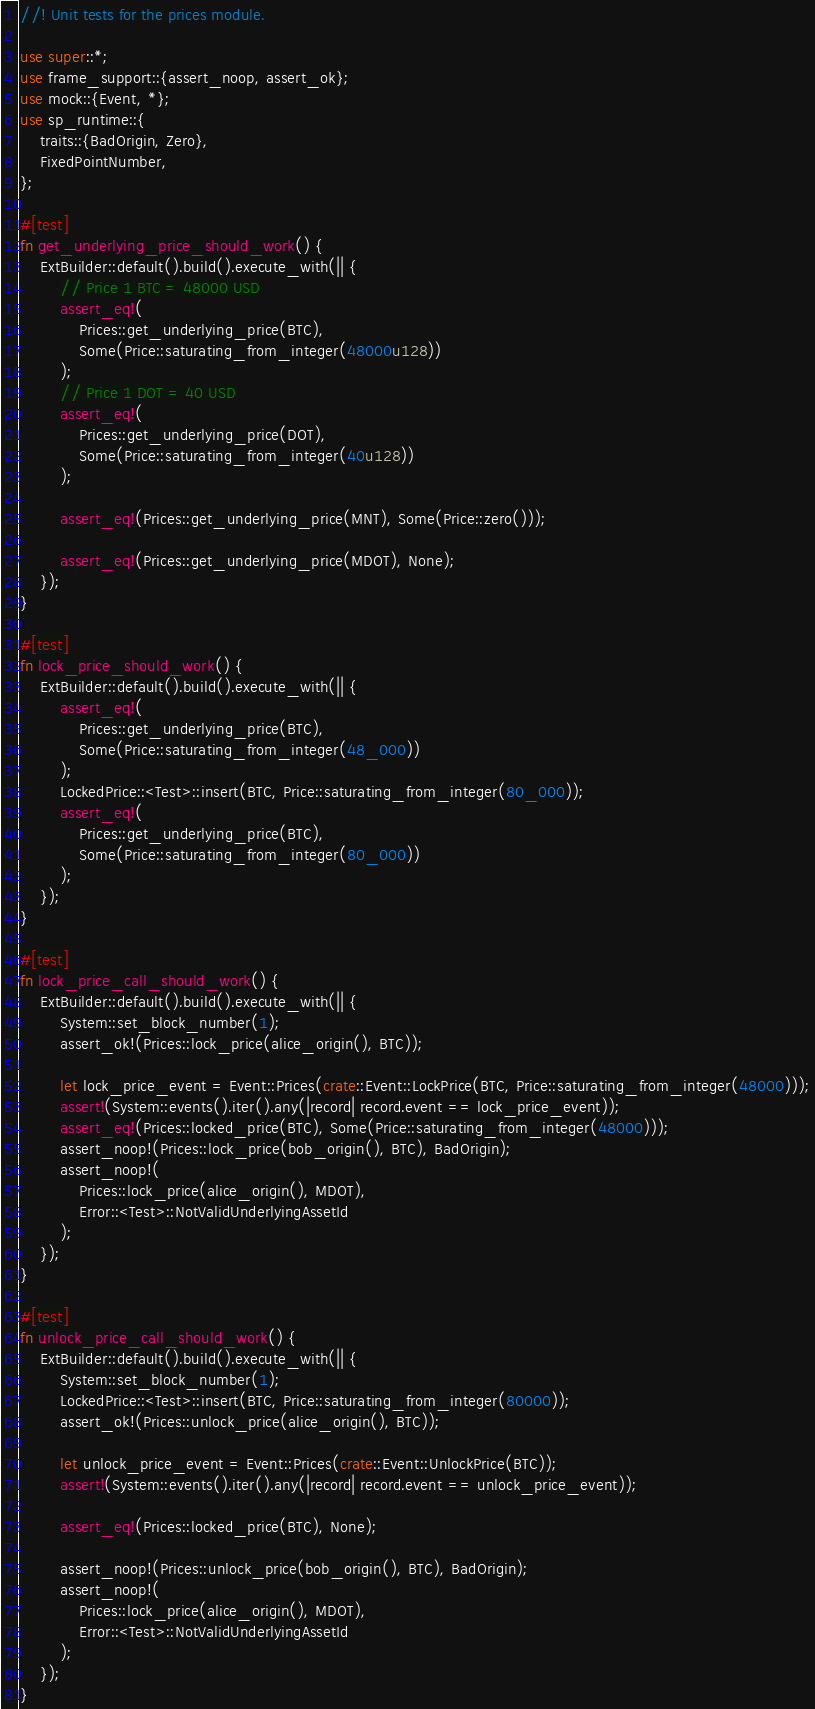<code> <loc_0><loc_0><loc_500><loc_500><_Rust_>//! Unit tests for the prices module.

use super::*;
use frame_support::{assert_noop, assert_ok};
use mock::{Event, *};
use sp_runtime::{
	traits::{BadOrigin, Zero},
	FixedPointNumber,
};

#[test]
fn get_underlying_price_should_work() {
	ExtBuilder::default().build().execute_with(|| {
		// Price 1 BTC = 48000 USD
		assert_eq!(
			Prices::get_underlying_price(BTC),
			Some(Price::saturating_from_integer(48000u128))
		);
		// Price 1 DOT = 40 USD
		assert_eq!(
			Prices::get_underlying_price(DOT),
			Some(Price::saturating_from_integer(40u128))
		);

		assert_eq!(Prices::get_underlying_price(MNT), Some(Price::zero()));

		assert_eq!(Prices::get_underlying_price(MDOT), None);
	});
}

#[test]
fn lock_price_should_work() {
	ExtBuilder::default().build().execute_with(|| {
		assert_eq!(
			Prices::get_underlying_price(BTC),
			Some(Price::saturating_from_integer(48_000))
		);
		LockedPrice::<Test>::insert(BTC, Price::saturating_from_integer(80_000));
		assert_eq!(
			Prices::get_underlying_price(BTC),
			Some(Price::saturating_from_integer(80_000))
		);
	});
}

#[test]
fn lock_price_call_should_work() {
	ExtBuilder::default().build().execute_with(|| {
		System::set_block_number(1);
		assert_ok!(Prices::lock_price(alice_origin(), BTC));

		let lock_price_event = Event::Prices(crate::Event::LockPrice(BTC, Price::saturating_from_integer(48000)));
		assert!(System::events().iter().any(|record| record.event == lock_price_event));
		assert_eq!(Prices::locked_price(BTC), Some(Price::saturating_from_integer(48000)));
		assert_noop!(Prices::lock_price(bob_origin(), BTC), BadOrigin);
		assert_noop!(
			Prices::lock_price(alice_origin(), MDOT),
			Error::<Test>::NotValidUnderlyingAssetId
		);
	});
}

#[test]
fn unlock_price_call_should_work() {
	ExtBuilder::default().build().execute_with(|| {
		System::set_block_number(1);
		LockedPrice::<Test>::insert(BTC, Price::saturating_from_integer(80000));
		assert_ok!(Prices::unlock_price(alice_origin(), BTC));

		let unlock_price_event = Event::Prices(crate::Event::UnlockPrice(BTC));
		assert!(System::events().iter().any(|record| record.event == unlock_price_event));

		assert_eq!(Prices::locked_price(BTC), None);

		assert_noop!(Prices::unlock_price(bob_origin(), BTC), BadOrigin);
		assert_noop!(
			Prices::lock_price(alice_origin(), MDOT),
			Error::<Test>::NotValidUnderlyingAssetId
		);
	});
}
</code> 